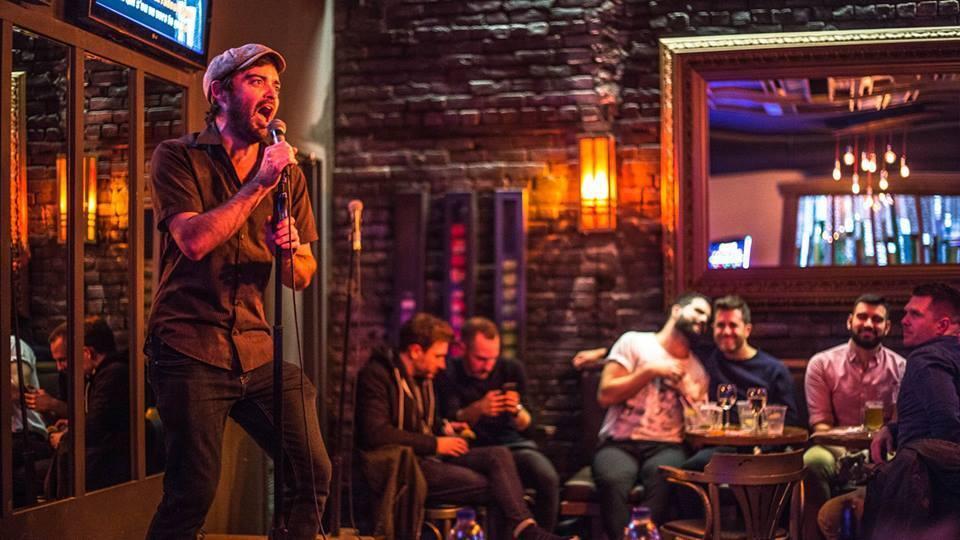What are other individuals in the picture doing and how do they contribute to the overall atmosphere? Other individuals in the scene are engaged in various activities: some are focused on their phones, likely sharing updates or capturing moments, while others are deeply engaged in conversations, contributing to a buzzing atmosphere. This diversity in engagement levels portrays a typical social scene in a bar where people are relaxed, enjoying the entertainment, and interacting in ways that suit their mood and company. 